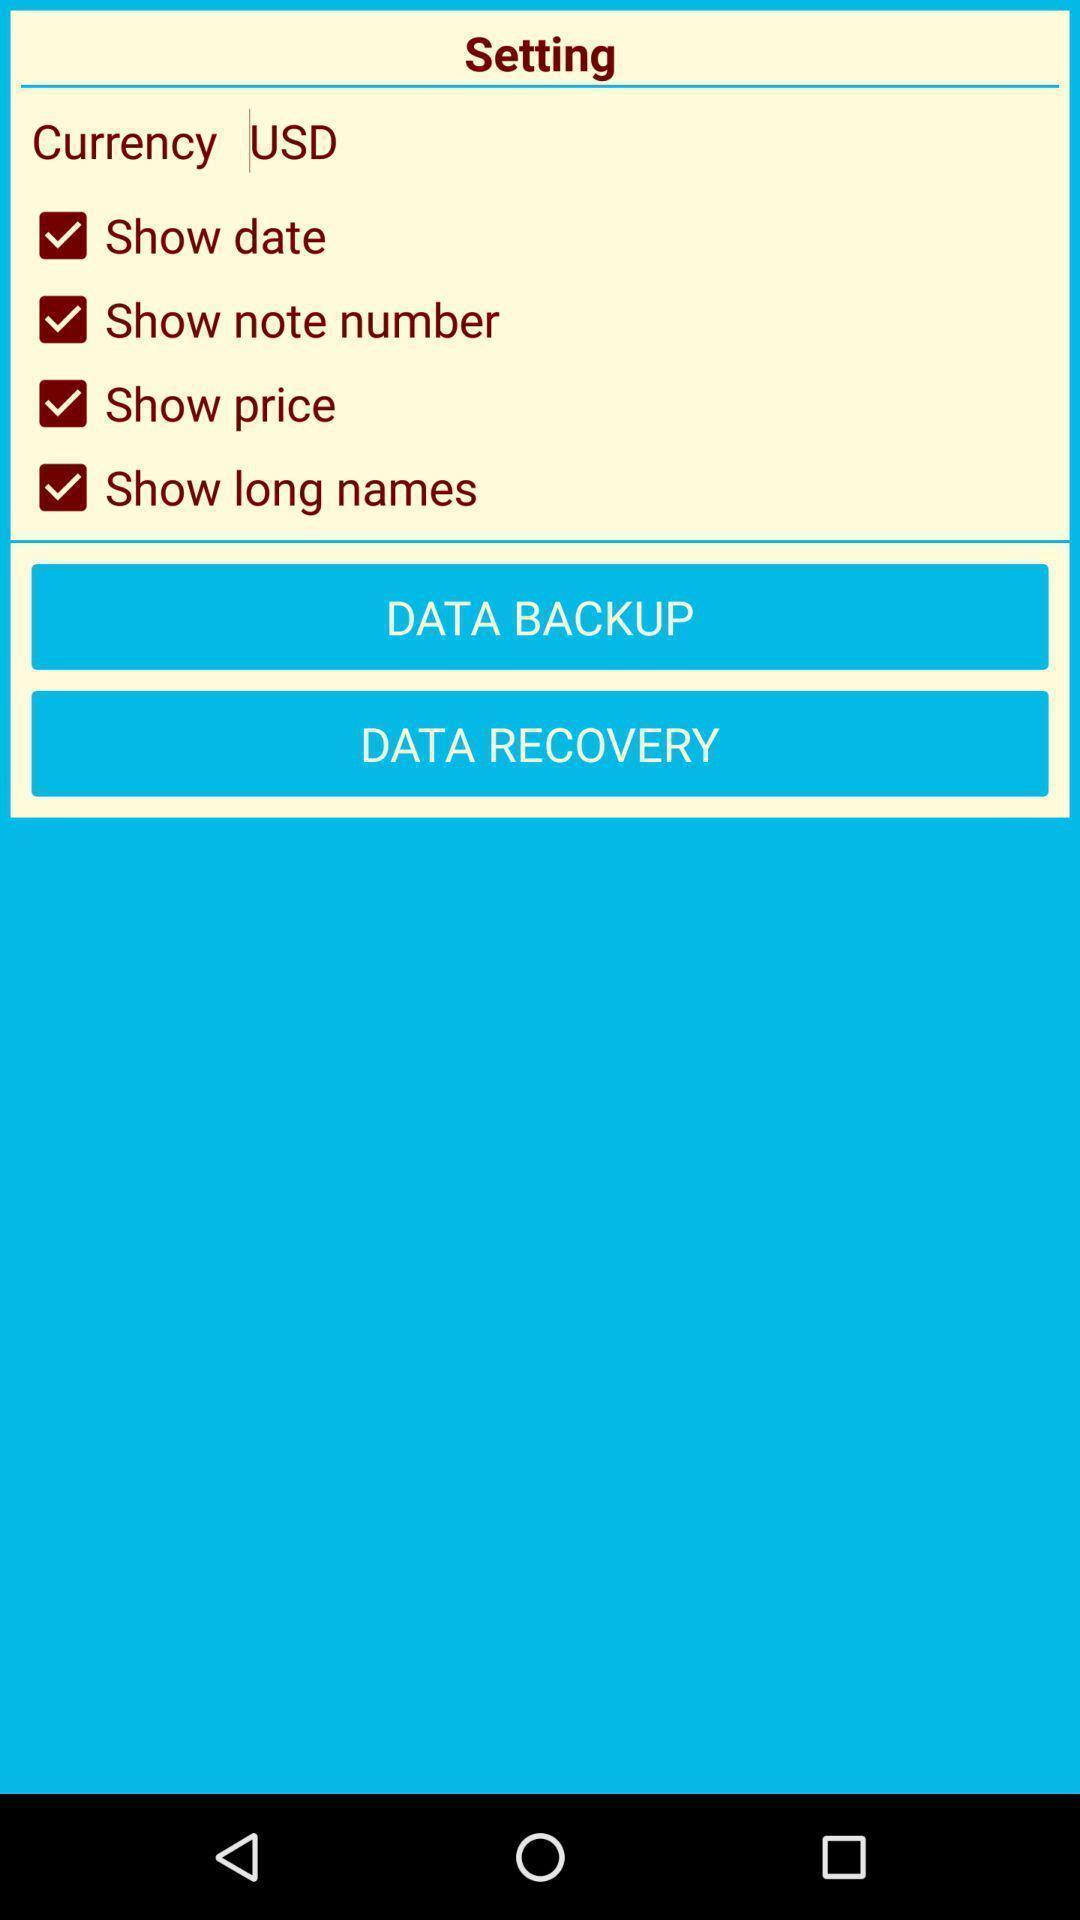Summarize the main components in this picture. Setting page. 